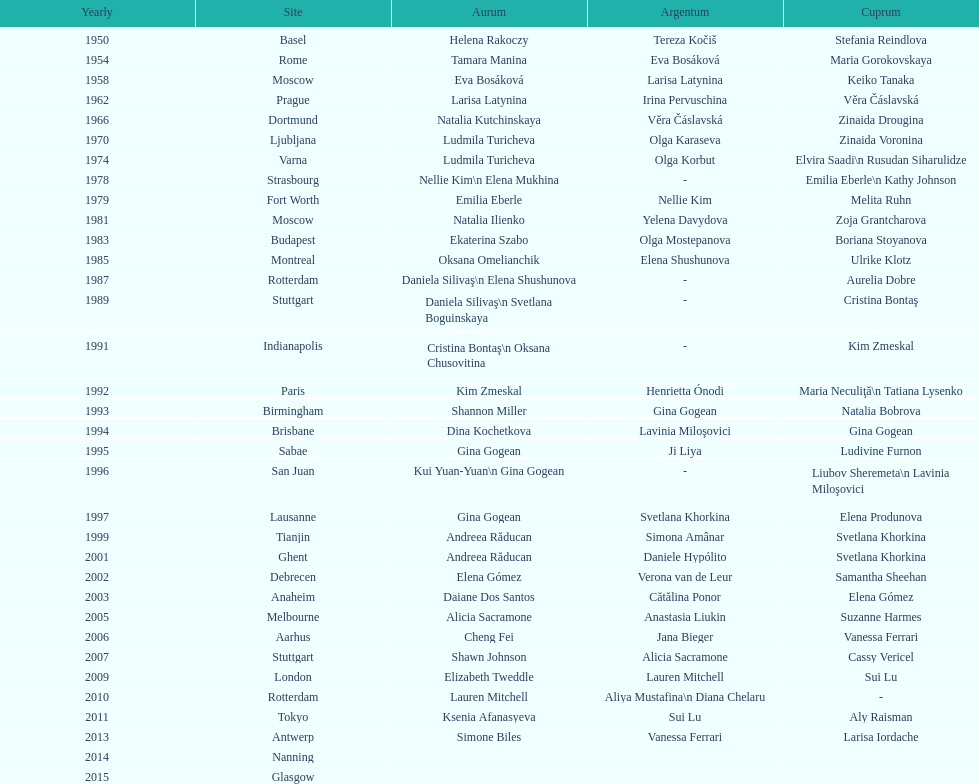Where did the world artistic gymnastics take place before san juan? Sabae. 